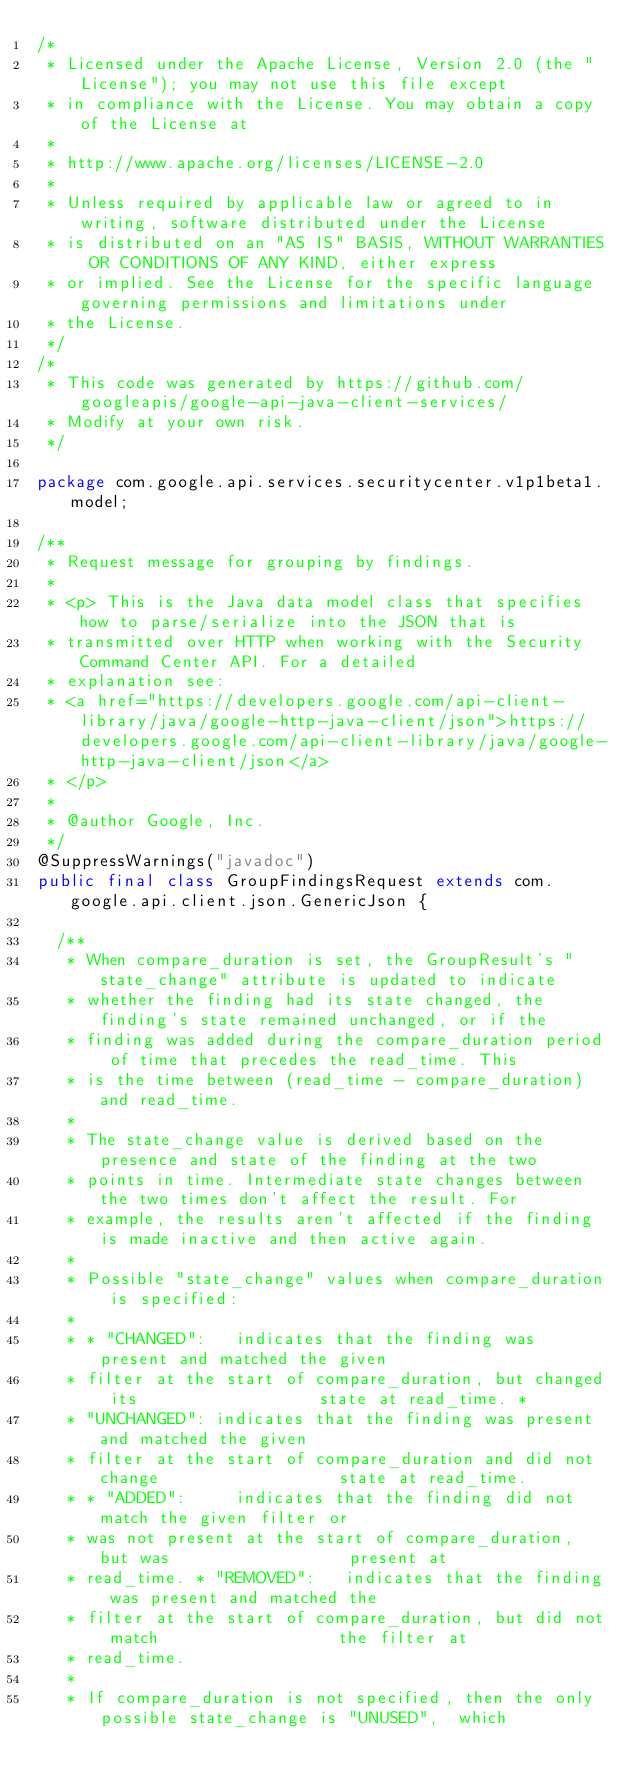Convert code to text. <code><loc_0><loc_0><loc_500><loc_500><_Java_>/*
 * Licensed under the Apache License, Version 2.0 (the "License"); you may not use this file except
 * in compliance with the License. You may obtain a copy of the License at
 *
 * http://www.apache.org/licenses/LICENSE-2.0
 *
 * Unless required by applicable law or agreed to in writing, software distributed under the License
 * is distributed on an "AS IS" BASIS, WITHOUT WARRANTIES OR CONDITIONS OF ANY KIND, either express
 * or implied. See the License for the specific language governing permissions and limitations under
 * the License.
 */
/*
 * This code was generated by https://github.com/googleapis/google-api-java-client-services/
 * Modify at your own risk.
 */

package com.google.api.services.securitycenter.v1p1beta1.model;

/**
 * Request message for grouping by findings.
 *
 * <p> This is the Java data model class that specifies how to parse/serialize into the JSON that is
 * transmitted over HTTP when working with the Security Command Center API. For a detailed
 * explanation see:
 * <a href="https://developers.google.com/api-client-library/java/google-http-java-client/json">https://developers.google.com/api-client-library/java/google-http-java-client/json</a>
 * </p>
 *
 * @author Google, Inc.
 */
@SuppressWarnings("javadoc")
public final class GroupFindingsRequest extends com.google.api.client.json.GenericJson {

  /**
   * When compare_duration is set, the GroupResult's "state_change" attribute is updated to indicate
   * whether the finding had its state changed, the finding's state remained unchanged, or if the
   * finding was added during the compare_duration period of time that precedes the read_time. This
   * is the time between (read_time - compare_duration) and read_time.
   *
   * The state_change value is derived based on the presence and state of the finding at the two
   * points in time. Intermediate state changes between the two times don't affect the result. For
   * example, the results aren't affected if the finding is made inactive and then active again.
   *
   * Possible "state_change" values when compare_duration is specified:
   *
   * * "CHANGED":   indicates that the finding was present and matched the given
   * filter at the start of compare_duration, but changed its                  state at read_time. *
   * "UNCHANGED": indicates that the finding was present and matched the given
   * filter at the start of compare_duration and did not change                  state at read_time.
   * * "ADDED":     indicates that the finding did not match the given filter or
   * was not present at the start of compare_duration, but was                  present at
   * read_time. * "REMOVED":   indicates that the finding was present and matched the
   * filter at the start of compare_duration, but did not match                  the filter at
   * read_time.
   *
   * If compare_duration is not specified, then the only possible state_change is "UNUSED",  which</code> 